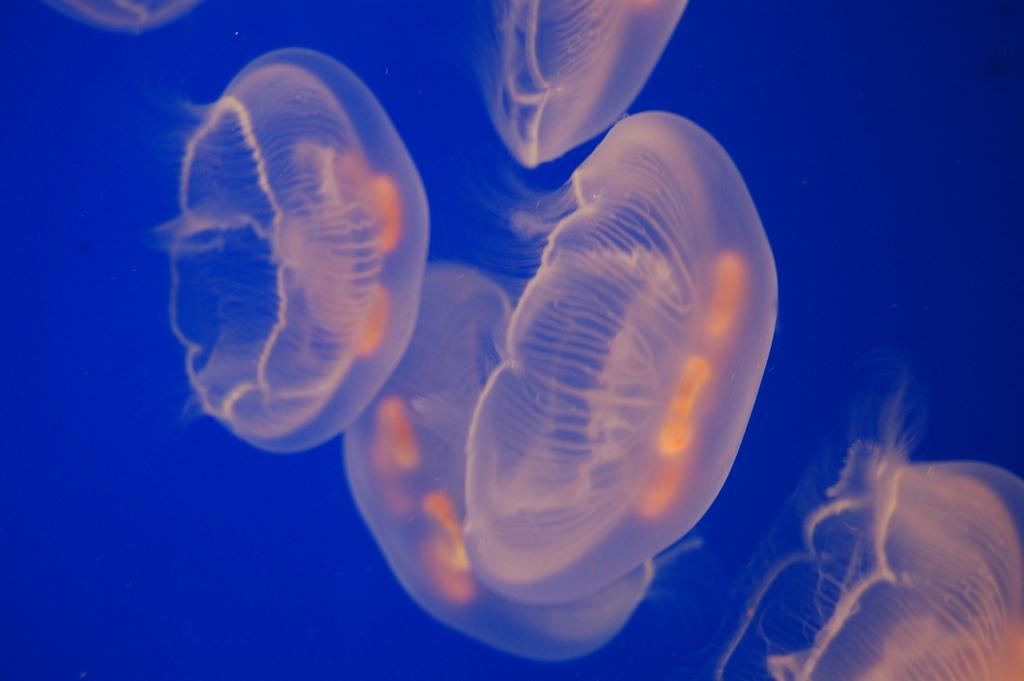What type of animals are in the image? There are jelly fishes in the image. Where are the jelly fishes located? The jelly fishes are in the water. What type of invention can be seen in the image? There is no invention present in the image; it features jelly fishes in the water. What color is the ink used by the jelly fishes in the image? There is no ink associated with the jelly fishes in the image, as they are living organisms in the water. 